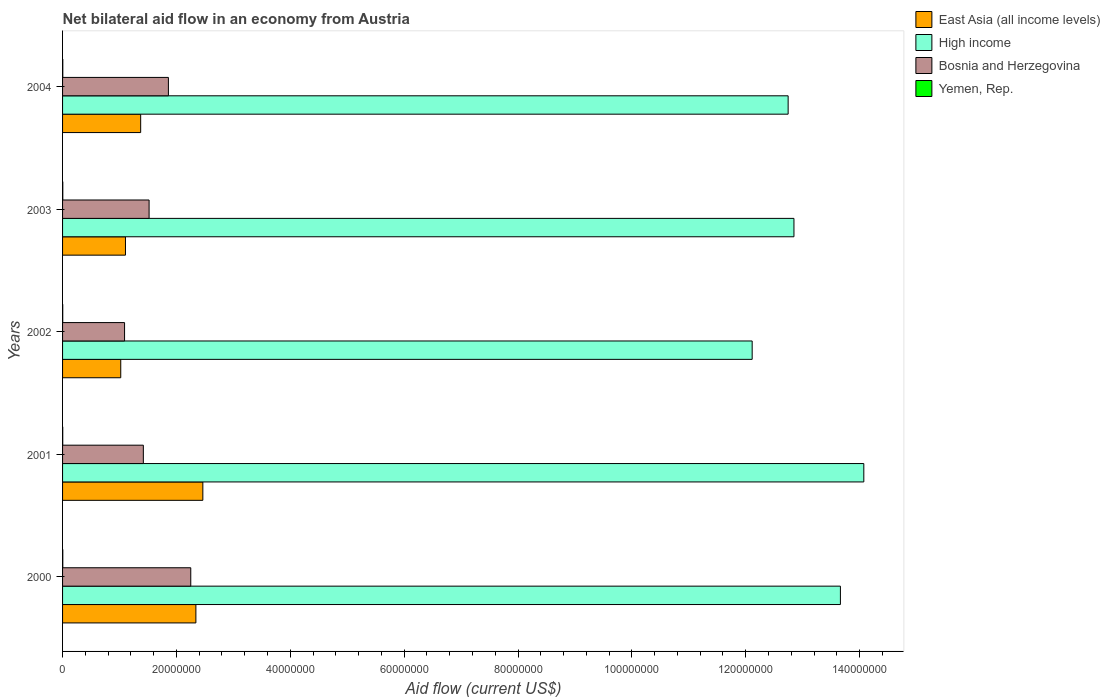How many different coloured bars are there?
Make the answer very short. 4. What is the net bilateral aid flow in High income in 2002?
Provide a short and direct response. 1.21e+08. Across all years, what is the maximum net bilateral aid flow in Yemen, Rep.?
Your answer should be compact. 4.00e+04. What is the total net bilateral aid flow in High income in the graph?
Ensure brevity in your answer.  6.54e+08. What is the difference between the net bilateral aid flow in East Asia (all income levels) in 2002 and that in 2004?
Give a very brief answer. -3.50e+06. What is the difference between the net bilateral aid flow in East Asia (all income levels) in 2004 and the net bilateral aid flow in Bosnia and Herzegovina in 2000?
Your response must be concise. -8.80e+06. What is the average net bilateral aid flow in High income per year?
Ensure brevity in your answer.  1.31e+08. In the year 2000, what is the difference between the net bilateral aid flow in Bosnia and Herzegovina and net bilateral aid flow in East Asia (all income levels)?
Your answer should be very brief. -9.00e+05. What is the ratio of the net bilateral aid flow in Bosnia and Herzegovina in 2000 to that in 2001?
Give a very brief answer. 1.59. Is the net bilateral aid flow in East Asia (all income levels) in 2001 less than that in 2004?
Provide a short and direct response. No. Is the difference between the net bilateral aid flow in Bosnia and Herzegovina in 2002 and 2003 greater than the difference between the net bilateral aid flow in East Asia (all income levels) in 2002 and 2003?
Ensure brevity in your answer.  No. What is the difference between the highest and the second highest net bilateral aid flow in Yemen, Rep.?
Keep it short and to the point. 0. What is the difference between the highest and the lowest net bilateral aid flow in East Asia (all income levels)?
Your response must be concise. 1.44e+07. Is it the case that in every year, the sum of the net bilateral aid flow in Yemen, Rep. and net bilateral aid flow in High income is greater than the sum of net bilateral aid flow in East Asia (all income levels) and net bilateral aid flow in Bosnia and Herzegovina?
Ensure brevity in your answer.  Yes. What does the 2nd bar from the top in 2003 represents?
Give a very brief answer. Bosnia and Herzegovina. Is it the case that in every year, the sum of the net bilateral aid flow in High income and net bilateral aid flow in Bosnia and Herzegovina is greater than the net bilateral aid flow in Yemen, Rep.?
Your response must be concise. Yes. Are all the bars in the graph horizontal?
Your answer should be very brief. Yes. How many years are there in the graph?
Ensure brevity in your answer.  5. Does the graph contain grids?
Your answer should be very brief. No. Where does the legend appear in the graph?
Your response must be concise. Top right. How many legend labels are there?
Your answer should be compact. 4. How are the legend labels stacked?
Offer a terse response. Vertical. What is the title of the graph?
Make the answer very short. Net bilateral aid flow in an economy from Austria. Does "South Sudan" appear as one of the legend labels in the graph?
Your answer should be compact. No. What is the Aid flow (current US$) in East Asia (all income levels) in 2000?
Give a very brief answer. 2.34e+07. What is the Aid flow (current US$) in High income in 2000?
Offer a terse response. 1.37e+08. What is the Aid flow (current US$) in Bosnia and Herzegovina in 2000?
Your answer should be compact. 2.25e+07. What is the Aid flow (current US$) of East Asia (all income levels) in 2001?
Offer a very short reply. 2.46e+07. What is the Aid flow (current US$) in High income in 2001?
Keep it short and to the point. 1.41e+08. What is the Aid flow (current US$) in Bosnia and Herzegovina in 2001?
Provide a succinct answer. 1.42e+07. What is the Aid flow (current US$) in East Asia (all income levels) in 2002?
Provide a short and direct response. 1.02e+07. What is the Aid flow (current US$) in High income in 2002?
Your answer should be very brief. 1.21e+08. What is the Aid flow (current US$) in Bosnia and Herzegovina in 2002?
Provide a succinct answer. 1.09e+07. What is the Aid flow (current US$) in East Asia (all income levels) in 2003?
Offer a very short reply. 1.10e+07. What is the Aid flow (current US$) of High income in 2003?
Offer a terse response. 1.28e+08. What is the Aid flow (current US$) in Bosnia and Herzegovina in 2003?
Ensure brevity in your answer.  1.52e+07. What is the Aid flow (current US$) of East Asia (all income levels) in 2004?
Offer a very short reply. 1.37e+07. What is the Aid flow (current US$) in High income in 2004?
Your answer should be compact. 1.27e+08. What is the Aid flow (current US$) in Bosnia and Herzegovina in 2004?
Provide a succinct answer. 1.86e+07. Across all years, what is the maximum Aid flow (current US$) of East Asia (all income levels)?
Offer a very short reply. 2.46e+07. Across all years, what is the maximum Aid flow (current US$) of High income?
Provide a succinct answer. 1.41e+08. Across all years, what is the maximum Aid flow (current US$) of Bosnia and Herzegovina?
Make the answer very short. 2.25e+07. Across all years, what is the minimum Aid flow (current US$) in East Asia (all income levels)?
Offer a terse response. 1.02e+07. Across all years, what is the minimum Aid flow (current US$) of High income?
Provide a short and direct response. 1.21e+08. Across all years, what is the minimum Aid flow (current US$) of Bosnia and Herzegovina?
Provide a short and direct response. 1.09e+07. Across all years, what is the minimum Aid flow (current US$) of Yemen, Rep.?
Your answer should be very brief. 3.00e+04. What is the total Aid flow (current US$) of East Asia (all income levels) in the graph?
Your response must be concise. 8.30e+07. What is the total Aid flow (current US$) of High income in the graph?
Ensure brevity in your answer.  6.54e+08. What is the total Aid flow (current US$) of Bosnia and Herzegovina in the graph?
Your answer should be compact. 8.14e+07. What is the total Aid flow (current US$) in Yemen, Rep. in the graph?
Provide a short and direct response. 1.80e+05. What is the difference between the Aid flow (current US$) in East Asia (all income levels) in 2000 and that in 2001?
Make the answer very short. -1.22e+06. What is the difference between the Aid flow (current US$) in High income in 2000 and that in 2001?
Make the answer very short. -4.11e+06. What is the difference between the Aid flow (current US$) in Bosnia and Herzegovina in 2000 and that in 2001?
Ensure brevity in your answer.  8.33e+06. What is the difference between the Aid flow (current US$) in East Asia (all income levels) in 2000 and that in 2002?
Provide a short and direct response. 1.32e+07. What is the difference between the Aid flow (current US$) in High income in 2000 and that in 2002?
Your answer should be compact. 1.55e+07. What is the difference between the Aid flow (current US$) of Bosnia and Herzegovina in 2000 and that in 2002?
Ensure brevity in your answer.  1.16e+07. What is the difference between the Aid flow (current US$) in East Asia (all income levels) in 2000 and that in 2003?
Give a very brief answer. 1.24e+07. What is the difference between the Aid flow (current US$) of High income in 2000 and that in 2003?
Your answer should be compact. 8.16e+06. What is the difference between the Aid flow (current US$) of Bosnia and Herzegovina in 2000 and that in 2003?
Your response must be concise. 7.32e+06. What is the difference between the Aid flow (current US$) of East Asia (all income levels) in 2000 and that in 2004?
Ensure brevity in your answer.  9.70e+06. What is the difference between the Aid flow (current US$) of High income in 2000 and that in 2004?
Provide a succinct answer. 9.18e+06. What is the difference between the Aid flow (current US$) of Bosnia and Herzegovina in 2000 and that in 2004?
Your answer should be very brief. 3.93e+06. What is the difference between the Aid flow (current US$) of Yemen, Rep. in 2000 and that in 2004?
Make the answer very short. 0. What is the difference between the Aid flow (current US$) of East Asia (all income levels) in 2001 and that in 2002?
Your answer should be very brief. 1.44e+07. What is the difference between the Aid flow (current US$) in High income in 2001 and that in 2002?
Make the answer very short. 1.96e+07. What is the difference between the Aid flow (current US$) of Bosnia and Herzegovina in 2001 and that in 2002?
Give a very brief answer. 3.30e+06. What is the difference between the Aid flow (current US$) of Yemen, Rep. in 2001 and that in 2002?
Give a very brief answer. 0. What is the difference between the Aid flow (current US$) in East Asia (all income levels) in 2001 and that in 2003?
Give a very brief answer. 1.36e+07. What is the difference between the Aid flow (current US$) of High income in 2001 and that in 2003?
Your response must be concise. 1.23e+07. What is the difference between the Aid flow (current US$) of Bosnia and Herzegovina in 2001 and that in 2003?
Provide a succinct answer. -1.01e+06. What is the difference between the Aid flow (current US$) of East Asia (all income levels) in 2001 and that in 2004?
Give a very brief answer. 1.09e+07. What is the difference between the Aid flow (current US$) in High income in 2001 and that in 2004?
Provide a short and direct response. 1.33e+07. What is the difference between the Aid flow (current US$) in Bosnia and Herzegovina in 2001 and that in 2004?
Make the answer very short. -4.40e+06. What is the difference between the Aid flow (current US$) of East Asia (all income levels) in 2002 and that in 2003?
Your answer should be very brief. -8.30e+05. What is the difference between the Aid flow (current US$) in High income in 2002 and that in 2003?
Keep it short and to the point. -7.34e+06. What is the difference between the Aid flow (current US$) of Bosnia and Herzegovina in 2002 and that in 2003?
Your answer should be very brief. -4.31e+06. What is the difference between the Aid flow (current US$) of Yemen, Rep. in 2002 and that in 2003?
Make the answer very short. -10000. What is the difference between the Aid flow (current US$) in East Asia (all income levels) in 2002 and that in 2004?
Your answer should be compact. -3.50e+06. What is the difference between the Aid flow (current US$) of High income in 2002 and that in 2004?
Your answer should be very brief. -6.32e+06. What is the difference between the Aid flow (current US$) in Bosnia and Herzegovina in 2002 and that in 2004?
Your answer should be very brief. -7.70e+06. What is the difference between the Aid flow (current US$) of East Asia (all income levels) in 2003 and that in 2004?
Offer a very short reply. -2.67e+06. What is the difference between the Aid flow (current US$) in High income in 2003 and that in 2004?
Give a very brief answer. 1.02e+06. What is the difference between the Aid flow (current US$) in Bosnia and Herzegovina in 2003 and that in 2004?
Ensure brevity in your answer.  -3.39e+06. What is the difference between the Aid flow (current US$) in East Asia (all income levels) in 2000 and the Aid flow (current US$) in High income in 2001?
Provide a succinct answer. -1.17e+08. What is the difference between the Aid flow (current US$) of East Asia (all income levels) in 2000 and the Aid flow (current US$) of Bosnia and Herzegovina in 2001?
Provide a succinct answer. 9.23e+06. What is the difference between the Aid flow (current US$) of East Asia (all income levels) in 2000 and the Aid flow (current US$) of Yemen, Rep. in 2001?
Keep it short and to the point. 2.34e+07. What is the difference between the Aid flow (current US$) in High income in 2000 and the Aid flow (current US$) in Bosnia and Herzegovina in 2001?
Provide a short and direct response. 1.22e+08. What is the difference between the Aid flow (current US$) in High income in 2000 and the Aid flow (current US$) in Yemen, Rep. in 2001?
Your answer should be compact. 1.37e+08. What is the difference between the Aid flow (current US$) in Bosnia and Herzegovina in 2000 and the Aid flow (current US$) in Yemen, Rep. in 2001?
Provide a succinct answer. 2.25e+07. What is the difference between the Aid flow (current US$) in East Asia (all income levels) in 2000 and the Aid flow (current US$) in High income in 2002?
Make the answer very short. -9.77e+07. What is the difference between the Aid flow (current US$) in East Asia (all income levels) in 2000 and the Aid flow (current US$) in Bosnia and Herzegovina in 2002?
Make the answer very short. 1.25e+07. What is the difference between the Aid flow (current US$) of East Asia (all income levels) in 2000 and the Aid flow (current US$) of Yemen, Rep. in 2002?
Your answer should be compact. 2.34e+07. What is the difference between the Aid flow (current US$) in High income in 2000 and the Aid flow (current US$) in Bosnia and Herzegovina in 2002?
Your answer should be compact. 1.26e+08. What is the difference between the Aid flow (current US$) of High income in 2000 and the Aid flow (current US$) of Yemen, Rep. in 2002?
Ensure brevity in your answer.  1.37e+08. What is the difference between the Aid flow (current US$) in Bosnia and Herzegovina in 2000 and the Aid flow (current US$) in Yemen, Rep. in 2002?
Your response must be concise. 2.25e+07. What is the difference between the Aid flow (current US$) in East Asia (all income levels) in 2000 and the Aid flow (current US$) in High income in 2003?
Your response must be concise. -1.05e+08. What is the difference between the Aid flow (current US$) in East Asia (all income levels) in 2000 and the Aid flow (current US$) in Bosnia and Herzegovina in 2003?
Make the answer very short. 8.22e+06. What is the difference between the Aid flow (current US$) in East Asia (all income levels) in 2000 and the Aid flow (current US$) in Yemen, Rep. in 2003?
Provide a succinct answer. 2.34e+07. What is the difference between the Aid flow (current US$) in High income in 2000 and the Aid flow (current US$) in Bosnia and Herzegovina in 2003?
Provide a succinct answer. 1.21e+08. What is the difference between the Aid flow (current US$) of High income in 2000 and the Aid flow (current US$) of Yemen, Rep. in 2003?
Provide a succinct answer. 1.37e+08. What is the difference between the Aid flow (current US$) of Bosnia and Herzegovina in 2000 and the Aid flow (current US$) of Yemen, Rep. in 2003?
Give a very brief answer. 2.25e+07. What is the difference between the Aid flow (current US$) in East Asia (all income levels) in 2000 and the Aid flow (current US$) in High income in 2004?
Provide a succinct answer. -1.04e+08. What is the difference between the Aid flow (current US$) of East Asia (all income levels) in 2000 and the Aid flow (current US$) of Bosnia and Herzegovina in 2004?
Give a very brief answer. 4.83e+06. What is the difference between the Aid flow (current US$) of East Asia (all income levels) in 2000 and the Aid flow (current US$) of Yemen, Rep. in 2004?
Provide a short and direct response. 2.34e+07. What is the difference between the Aid flow (current US$) of High income in 2000 and the Aid flow (current US$) of Bosnia and Herzegovina in 2004?
Provide a succinct answer. 1.18e+08. What is the difference between the Aid flow (current US$) of High income in 2000 and the Aid flow (current US$) of Yemen, Rep. in 2004?
Offer a terse response. 1.37e+08. What is the difference between the Aid flow (current US$) of Bosnia and Herzegovina in 2000 and the Aid flow (current US$) of Yemen, Rep. in 2004?
Offer a very short reply. 2.25e+07. What is the difference between the Aid flow (current US$) of East Asia (all income levels) in 2001 and the Aid flow (current US$) of High income in 2002?
Make the answer very short. -9.65e+07. What is the difference between the Aid flow (current US$) of East Asia (all income levels) in 2001 and the Aid flow (current US$) of Bosnia and Herzegovina in 2002?
Make the answer very short. 1.38e+07. What is the difference between the Aid flow (current US$) of East Asia (all income levels) in 2001 and the Aid flow (current US$) of Yemen, Rep. in 2002?
Give a very brief answer. 2.46e+07. What is the difference between the Aid flow (current US$) of High income in 2001 and the Aid flow (current US$) of Bosnia and Herzegovina in 2002?
Your answer should be compact. 1.30e+08. What is the difference between the Aid flow (current US$) in High income in 2001 and the Aid flow (current US$) in Yemen, Rep. in 2002?
Ensure brevity in your answer.  1.41e+08. What is the difference between the Aid flow (current US$) of Bosnia and Herzegovina in 2001 and the Aid flow (current US$) of Yemen, Rep. in 2002?
Make the answer very short. 1.42e+07. What is the difference between the Aid flow (current US$) of East Asia (all income levels) in 2001 and the Aid flow (current US$) of High income in 2003?
Your answer should be very brief. -1.04e+08. What is the difference between the Aid flow (current US$) of East Asia (all income levels) in 2001 and the Aid flow (current US$) of Bosnia and Herzegovina in 2003?
Give a very brief answer. 9.44e+06. What is the difference between the Aid flow (current US$) of East Asia (all income levels) in 2001 and the Aid flow (current US$) of Yemen, Rep. in 2003?
Provide a succinct answer. 2.46e+07. What is the difference between the Aid flow (current US$) of High income in 2001 and the Aid flow (current US$) of Bosnia and Herzegovina in 2003?
Provide a short and direct response. 1.26e+08. What is the difference between the Aid flow (current US$) of High income in 2001 and the Aid flow (current US$) of Yemen, Rep. in 2003?
Offer a terse response. 1.41e+08. What is the difference between the Aid flow (current US$) of Bosnia and Herzegovina in 2001 and the Aid flow (current US$) of Yemen, Rep. in 2003?
Make the answer very short. 1.42e+07. What is the difference between the Aid flow (current US$) in East Asia (all income levels) in 2001 and the Aid flow (current US$) in High income in 2004?
Ensure brevity in your answer.  -1.03e+08. What is the difference between the Aid flow (current US$) in East Asia (all income levels) in 2001 and the Aid flow (current US$) in Bosnia and Herzegovina in 2004?
Make the answer very short. 6.05e+06. What is the difference between the Aid flow (current US$) of East Asia (all income levels) in 2001 and the Aid flow (current US$) of Yemen, Rep. in 2004?
Provide a short and direct response. 2.46e+07. What is the difference between the Aid flow (current US$) in High income in 2001 and the Aid flow (current US$) in Bosnia and Herzegovina in 2004?
Provide a short and direct response. 1.22e+08. What is the difference between the Aid flow (current US$) of High income in 2001 and the Aid flow (current US$) of Yemen, Rep. in 2004?
Ensure brevity in your answer.  1.41e+08. What is the difference between the Aid flow (current US$) in Bosnia and Herzegovina in 2001 and the Aid flow (current US$) in Yemen, Rep. in 2004?
Keep it short and to the point. 1.42e+07. What is the difference between the Aid flow (current US$) in East Asia (all income levels) in 2002 and the Aid flow (current US$) in High income in 2003?
Make the answer very short. -1.18e+08. What is the difference between the Aid flow (current US$) of East Asia (all income levels) in 2002 and the Aid flow (current US$) of Bosnia and Herzegovina in 2003?
Offer a terse response. -4.98e+06. What is the difference between the Aid flow (current US$) of East Asia (all income levels) in 2002 and the Aid flow (current US$) of Yemen, Rep. in 2003?
Your answer should be compact. 1.02e+07. What is the difference between the Aid flow (current US$) in High income in 2002 and the Aid flow (current US$) in Bosnia and Herzegovina in 2003?
Offer a very short reply. 1.06e+08. What is the difference between the Aid flow (current US$) of High income in 2002 and the Aid flow (current US$) of Yemen, Rep. in 2003?
Give a very brief answer. 1.21e+08. What is the difference between the Aid flow (current US$) of Bosnia and Herzegovina in 2002 and the Aid flow (current US$) of Yemen, Rep. in 2003?
Give a very brief answer. 1.08e+07. What is the difference between the Aid flow (current US$) of East Asia (all income levels) in 2002 and the Aid flow (current US$) of High income in 2004?
Offer a very short reply. -1.17e+08. What is the difference between the Aid flow (current US$) in East Asia (all income levels) in 2002 and the Aid flow (current US$) in Bosnia and Herzegovina in 2004?
Your response must be concise. -8.37e+06. What is the difference between the Aid flow (current US$) of East Asia (all income levels) in 2002 and the Aid flow (current US$) of Yemen, Rep. in 2004?
Make the answer very short. 1.02e+07. What is the difference between the Aid flow (current US$) in High income in 2002 and the Aid flow (current US$) in Bosnia and Herzegovina in 2004?
Your response must be concise. 1.03e+08. What is the difference between the Aid flow (current US$) of High income in 2002 and the Aid flow (current US$) of Yemen, Rep. in 2004?
Your response must be concise. 1.21e+08. What is the difference between the Aid flow (current US$) of Bosnia and Herzegovina in 2002 and the Aid flow (current US$) of Yemen, Rep. in 2004?
Provide a succinct answer. 1.08e+07. What is the difference between the Aid flow (current US$) in East Asia (all income levels) in 2003 and the Aid flow (current US$) in High income in 2004?
Provide a short and direct response. -1.16e+08. What is the difference between the Aid flow (current US$) in East Asia (all income levels) in 2003 and the Aid flow (current US$) in Bosnia and Herzegovina in 2004?
Provide a short and direct response. -7.54e+06. What is the difference between the Aid flow (current US$) of East Asia (all income levels) in 2003 and the Aid flow (current US$) of Yemen, Rep. in 2004?
Offer a terse response. 1.10e+07. What is the difference between the Aid flow (current US$) in High income in 2003 and the Aid flow (current US$) in Bosnia and Herzegovina in 2004?
Make the answer very short. 1.10e+08. What is the difference between the Aid flow (current US$) of High income in 2003 and the Aid flow (current US$) of Yemen, Rep. in 2004?
Make the answer very short. 1.28e+08. What is the difference between the Aid flow (current US$) of Bosnia and Herzegovina in 2003 and the Aid flow (current US$) of Yemen, Rep. in 2004?
Offer a terse response. 1.52e+07. What is the average Aid flow (current US$) in East Asia (all income levels) per year?
Your response must be concise. 1.66e+07. What is the average Aid flow (current US$) in High income per year?
Offer a terse response. 1.31e+08. What is the average Aid flow (current US$) of Bosnia and Herzegovina per year?
Your answer should be very brief. 1.63e+07. What is the average Aid flow (current US$) of Yemen, Rep. per year?
Offer a very short reply. 3.60e+04. In the year 2000, what is the difference between the Aid flow (current US$) of East Asia (all income levels) and Aid flow (current US$) of High income?
Keep it short and to the point. -1.13e+08. In the year 2000, what is the difference between the Aid flow (current US$) of East Asia (all income levels) and Aid flow (current US$) of Bosnia and Herzegovina?
Keep it short and to the point. 9.00e+05. In the year 2000, what is the difference between the Aid flow (current US$) in East Asia (all income levels) and Aid flow (current US$) in Yemen, Rep.?
Keep it short and to the point. 2.34e+07. In the year 2000, what is the difference between the Aid flow (current US$) in High income and Aid flow (current US$) in Bosnia and Herzegovina?
Your answer should be compact. 1.14e+08. In the year 2000, what is the difference between the Aid flow (current US$) of High income and Aid flow (current US$) of Yemen, Rep.?
Give a very brief answer. 1.37e+08. In the year 2000, what is the difference between the Aid flow (current US$) in Bosnia and Herzegovina and Aid flow (current US$) in Yemen, Rep.?
Your response must be concise. 2.25e+07. In the year 2001, what is the difference between the Aid flow (current US$) of East Asia (all income levels) and Aid flow (current US$) of High income?
Your answer should be compact. -1.16e+08. In the year 2001, what is the difference between the Aid flow (current US$) of East Asia (all income levels) and Aid flow (current US$) of Bosnia and Herzegovina?
Ensure brevity in your answer.  1.04e+07. In the year 2001, what is the difference between the Aid flow (current US$) of East Asia (all income levels) and Aid flow (current US$) of Yemen, Rep.?
Offer a terse response. 2.46e+07. In the year 2001, what is the difference between the Aid flow (current US$) in High income and Aid flow (current US$) in Bosnia and Herzegovina?
Keep it short and to the point. 1.27e+08. In the year 2001, what is the difference between the Aid flow (current US$) in High income and Aid flow (current US$) in Yemen, Rep.?
Your response must be concise. 1.41e+08. In the year 2001, what is the difference between the Aid flow (current US$) of Bosnia and Herzegovina and Aid flow (current US$) of Yemen, Rep.?
Provide a succinct answer. 1.42e+07. In the year 2002, what is the difference between the Aid flow (current US$) of East Asia (all income levels) and Aid flow (current US$) of High income?
Your answer should be very brief. -1.11e+08. In the year 2002, what is the difference between the Aid flow (current US$) of East Asia (all income levels) and Aid flow (current US$) of Bosnia and Herzegovina?
Provide a succinct answer. -6.70e+05. In the year 2002, what is the difference between the Aid flow (current US$) in East Asia (all income levels) and Aid flow (current US$) in Yemen, Rep.?
Provide a succinct answer. 1.02e+07. In the year 2002, what is the difference between the Aid flow (current US$) in High income and Aid flow (current US$) in Bosnia and Herzegovina?
Give a very brief answer. 1.10e+08. In the year 2002, what is the difference between the Aid flow (current US$) in High income and Aid flow (current US$) in Yemen, Rep.?
Your answer should be compact. 1.21e+08. In the year 2002, what is the difference between the Aid flow (current US$) of Bosnia and Herzegovina and Aid flow (current US$) of Yemen, Rep.?
Offer a terse response. 1.09e+07. In the year 2003, what is the difference between the Aid flow (current US$) in East Asia (all income levels) and Aid flow (current US$) in High income?
Keep it short and to the point. -1.17e+08. In the year 2003, what is the difference between the Aid flow (current US$) of East Asia (all income levels) and Aid flow (current US$) of Bosnia and Herzegovina?
Keep it short and to the point. -4.15e+06. In the year 2003, what is the difference between the Aid flow (current US$) of East Asia (all income levels) and Aid flow (current US$) of Yemen, Rep.?
Provide a short and direct response. 1.10e+07. In the year 2003, what is the difference between the Aid flow (current US$) in High income and Aid flow (current US$) in Bosnia and Herzegovina?
Offer a very short reply. 1.13e+08. In the year 2003, what is the difference between the Aid flow (current US$) in High income and Aid flow (current US$) in Yemen, Rep.?
Offer a very short reply. 1.28e+08. In the year 2003, what is the difference between the Aid flow (current US$) of Bosnia and Herzegovina and Aid flow (current US$) of Yemen, Rep.?
Your response must be concise. 1.52e+07. In the year 2004, what is the difference between the Aid flow (current US$) of East Asia (all income levels) and Aid flow (current US$) of High income?
Give a very brief answer. -1.14e+08. In the year 2004, what is the difference between the Aid flow (current US$) of East Asia (all income levels) and Aid flow (current US$) of Bosnia and Herzegovina?
Your answer should be very brief. -4.87e+06. In the year 2004, what is the difference between the Aid flow (current US$) in East Asia (all income levels) and Aid flow (current US$) in Yemen, Rep.?
Offer a terse response. 1.37e+07. In the year 2004, what is the difference between the Aid flow (current US$) in High income and Aid flow (current US$) in Bosnia and Herzegovina?
Your answer should be very brief. 1.09e+08. In the year 2004, what is the difference between the Aid flow (current US$) in High income and Aid flow (current US$) in Yemen, Rep.?
Provide a short and direct response. 1.27e+08. In the year 2004, what is the difference between the Aid flow (current US$) of Bosnia and Herzegovina and Aid flow (current US$) of Yemen, Rep.?
Offer a terse response. 1.86e+07. What is the ratio of the Aid flow (current US$) in East Asia (all income levels) in 2000 to that in 2001?
Offer a very short reply. 0.95. What is the ratio of the Aid flow (current US$) of High income in 2000 to that in 2001?
Provide a short and direct response. 0.97. What is the ratio of the Aid flow (current US$) in Bosnia and Herzegovina in 2000 to that in 2001?
Your answer should be compact. 1.59. What is the ratio of the Aid flow (current US$) in Yemen, Rep. in 2000 to that in 2001?
Your response must be concise. 1.33. What is the ratio of the Aid flow (current US$) of East Asia (all income levels) in 2000 to that in 2002?
Your answer should be compact. 2.29. What is the ratio of the Aid flow (current US$) in High income in 2000 to that in 2002?
Ensure brevity in your answer.  1.13. What is the ratio of the Aid flow (current US$) in Bosnia and Herzegovina in 2000 to that in 2002?
Your answer should be very brief. 2.07. What is the ratio of the Aid flow (current US$) of Yemen, Rep. in 2000 to that in 2002?
Give a very brief answer. 1.33. What is the ratio of the Aid flow (current US$) of East Asia (all income levels) in 2000 to that in 2003?
Your answer should be compact. 2.12. What is the ratio of the Aid flow (current US$) of High income in 2000 to that in 2003?
Give a very brief answer. 1.06. What is the ratio of the Aid flow (current US$) of Bosnia and Herzegovina in 2000 to that in 2003?
Keep it short and to the point. 1.48. What is the ratio of the Aid flow (current US$) of East Asia (all income levels) in 2000 to that in 2004?
Give a very brief answer. 1.71. What is the ratio of the Aid flow (current US$) in High income in 2000 to that in 2004?
Your answer should be very brief. 1.07. What is the ratio of the Aid flow (current US$) in Bosnia and Herzegovina in 2000 to that in 2004?
Offer a very short reply. 1.21. What is the ratio of the Aid flow (current US$) of Yemen, Rep. in 2000 to that in 2004?
Offer a very short reply. 1. What is the ratio of the Aid flow (current US$) of East Asia (all income levels) in 2001 to that in 2002?
Your response must be concise. 2.41. What is the ratio of the Aid flow (current US$) in High income in 2001 to that in 2002?
Make the answer very short. 1.16. What is the ratio of the Aid flow (current US$) of Bosnia and Herzegovina in 2001 to that in 2002?
Your response must be concise. 1.3. What is the ratio of the Aid flow (current US$) in East Asia (all income levels) in 2001 to that in 2003?
Your response must be concise. 2.23. What is the ratio of the Aid flow (current US$) in High income in 2001 to that in 2003?
Your answer should be compact. 1.1. What is the ratio of the Aid flow (current US$) of Bosnia and Herzegovina in 2001 to that in 2003?
Provide a short and direct response. 0.93. What is the ratio of the Aid flow (current US$) in Yemen, Rep. in 2001 to that in 2003?
Your answer should be very brief. 0.75. What is the ratio of the Aid flow (current US$) of East Asia (all income levels) in 2001 to that in 2004?
Keep it short and to the point. 1.8. What is the ratio of the Aid flow (current US$) in High income in 2001 to that in 2004?
Offer a very short reply. 1.1. What is the ratio of the Aid flow (current US$) in Bosnia and Herzegovina in 2001 to that in 2004?
Your answer should be compact. 0.76. What is the ratio of the Aid flow (current US$) in East Asia (all income levels) in 2002 to that in 2003?
Give a very brief answer. 0.92. What is the ratio of the Aid flow (current US$) in High income in 2002 to that in 2003?
Offer a very short reply. 0.94. What is the ratio of the Aid flow (current US$) in Bosnia and Herzegovina in 2002 to that in 2003?
Provide a short and direct response. 0.72. What is the ratio of the Aid flow (current US$) of Yemen, Rep. in 2002 to that in 2003?
Make the answer very short. 0.75. What is the ratio of the Aid flow (current US$) of East Asia (all income levels) in 2002 to that in 2004?
Keep it short and to the point. 0.74. What is the ratio of the Aid flow (current US$) of High income in 2002 to that in 2004?
Offer a very short reply. 0.95. What is the ratio of the Aid flow (current US$) in Bosnia and Herzegovina in 2002 to that in 2004?
Ensure brevity in your answer.  0.59. What is the ratio of the Aid flow (current US$) of Yemen, Rep. in 2002 to that in 2004?
Your answer should be very brief. 0.75. What is the ratio of the Aid flow (current US$) in East Asia (all income levels) in 2003 to that in 2004?
Keep it short and to the point. 0.81. What is the ratio of the Aid flow (current US$) of High income in 2003 to that in 2004?
Provide a short and direct response. 1.01. What is the ratio of the Aid flow (current US$) in Bosnia and Herzegovina in 2003 to that in 2004?
Ensure brevity in your answer.  0.82. What is the ratio of the Aid flow (current US$) in Yemen, Rep. in 2003 to that in 2004?
Offer a very short reply. 1. What is the difference between the highest and the second highest Aid flow (current US$) in East Asia (all income levels)?
Keep it short and to the point. 1.22e+06. What is the difference between the highest and the second highest Aid flow (current US$) of High income?
Provide a short and direct response. 4.11e+06. What is the difference between the highest and the second highest Aid flow (current US$) of Bosnia and Herzegovina?
Offer a very short reply. 3.93e+06. What is the difference between the highest and the lowest Aid flow (current US$) of East Asia (all income levels)?
Offer a very short reply. 1.44e+07. What is the difference between the highest and the lowest Aid flow (current US$) in High income?
Offer a terse response. 1.96e+07. What is the difference between the highest and the lowest Aid flow (current US$) of Bosnia and Herzegovina?
Provide a succinct answer. 1.16e+07. What is the difference between the highest and the lowest Aid flow (current US$) of Yemen, Rep.?
Ensure brevity in your answer.  10000. 